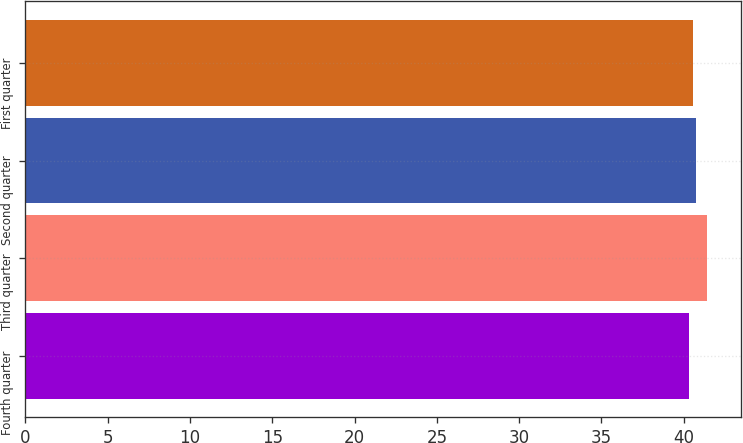Convert chart. <chart><loc_0><loc_0><loc_500><loc_500><bar_chart><fcel>Fourth quarter<fcel>Third quarter<fcel>Second quarter<fcel>First quarter<nl><fcel>40.31<fcel>41.39<fcel>40.74<fcel>40.55<nl></chart> 